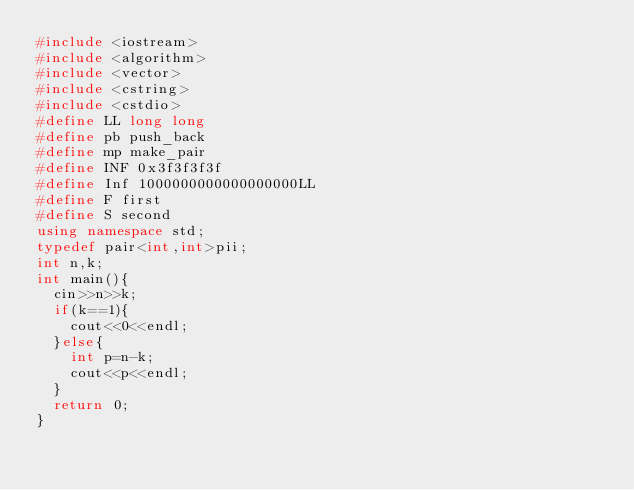<code> <loc_0><loc_0><loc_500><loc_500><_C++_>#include <iostream>
#include <algorithm>
#include <vector>
#include <cstring>
#include <cstdio>
#define LL long long
#define pb push_back
#define mp make_pair
#define INF 0x3f3f3f3f
#define Inf 1000000000000000000LL
#define F first
#define S second
using namespace std;
typedef pair<int,int>pii;
int n,k;
int main(){
	cin>>n>>k;
	if(k==1){
		cout<<0<<endl;
	}else{
		int p=n-k;
		cout<<p<<endl;
	}
	return 0;
}</code> 